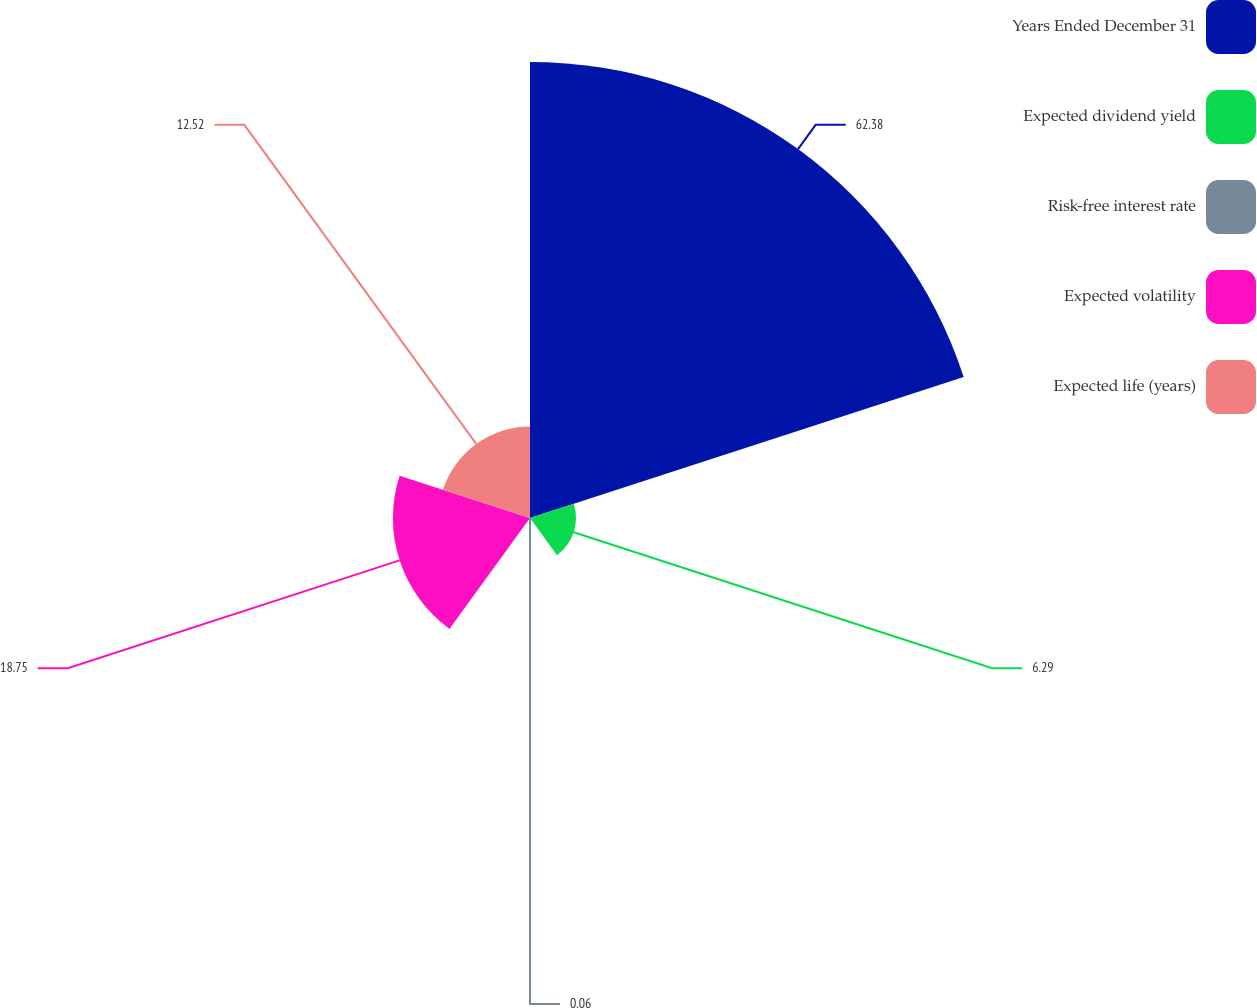<chart> <loc_0><loc_0><loc_500><loc_500><pie_chart><fcel>Years Ended December 31<fcel>Expected dividend yield<fcel>Risk-free interest rate<fcel>Expected volatility<fcel>Expected life (years)<nl><fcel>62.37%<fcel>6.29%<fcel>0.06%<fcel>18.75%<fcel>12.52%<nl></chart> 